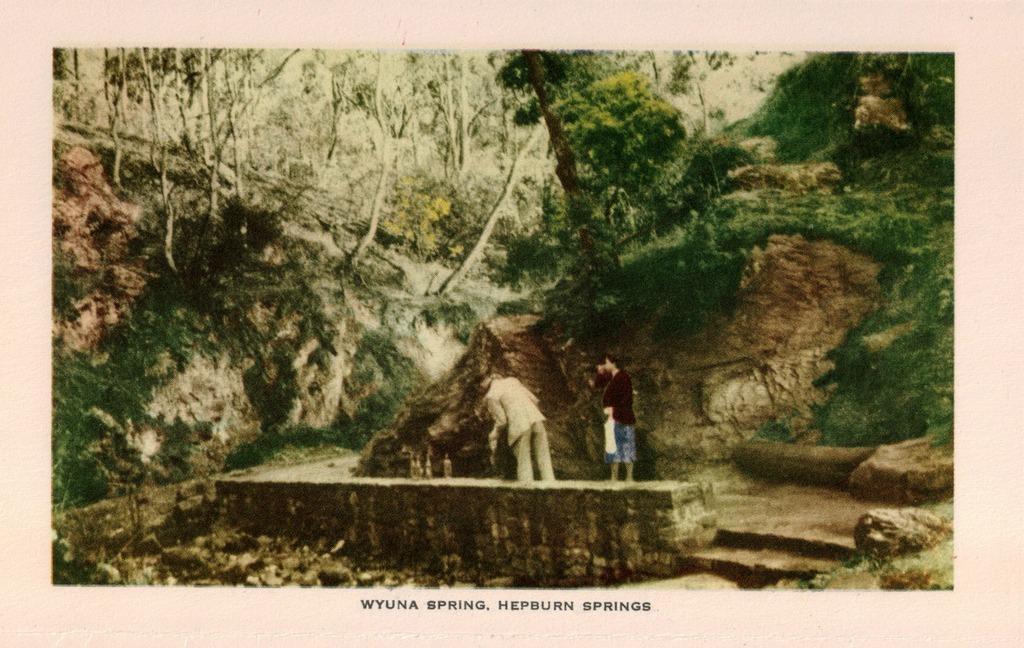In one or two sentences, can you explain what this image depicts? This is an edited image. In the middle of the image there are two persons standing on a wall. In the background there are hills and many trees. At the bottom of this image there is some text. 